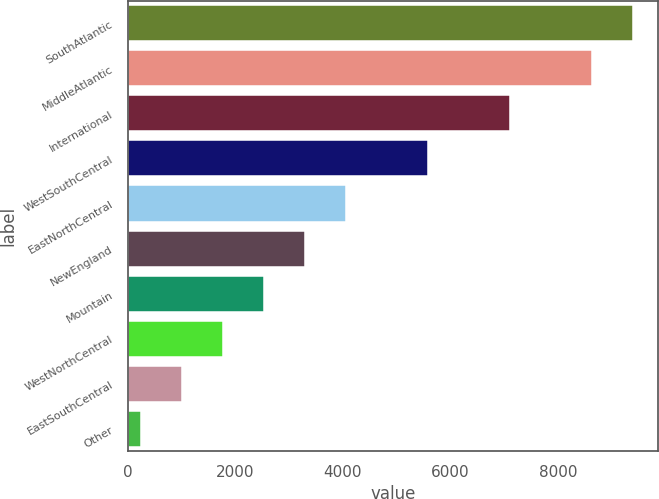Convert chart. <chart><loc_0><loc_0><loc_500><loc_500><bar_chart><fcel>SouthAtlantic<fcel>MiddleAtlantic<fcel>International<fcel>WestSouthCentral<fcel>EastNorthCentral<fcel>NewEngland<fcel>Mountain<fcel>WestNorthCentral<fcel>EastSouthCentral<fcel>Other<nl><fcel>9394<fcel>8632<fcel>7108<fcel>5584<fcel>4060<fcel>3298<fcel>2536<fcel>1774<fcel>1012<fcel>250<nl></chart> 